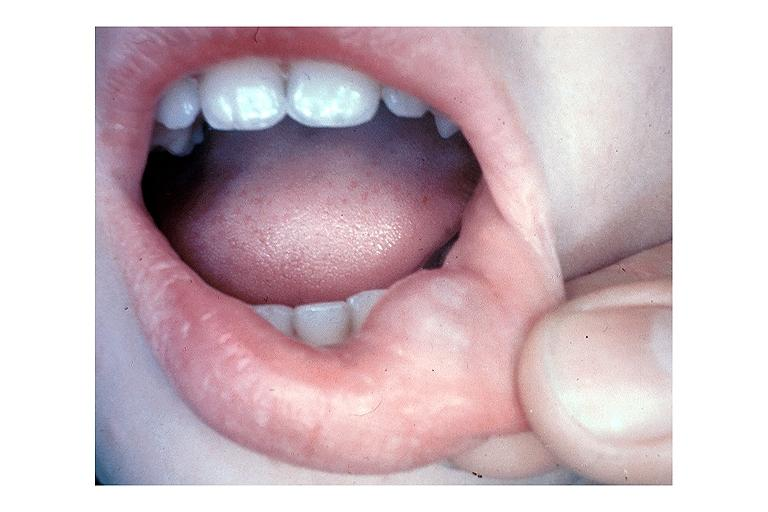does uterus show mucocele?
Answer the question using a single word or phrase. No 